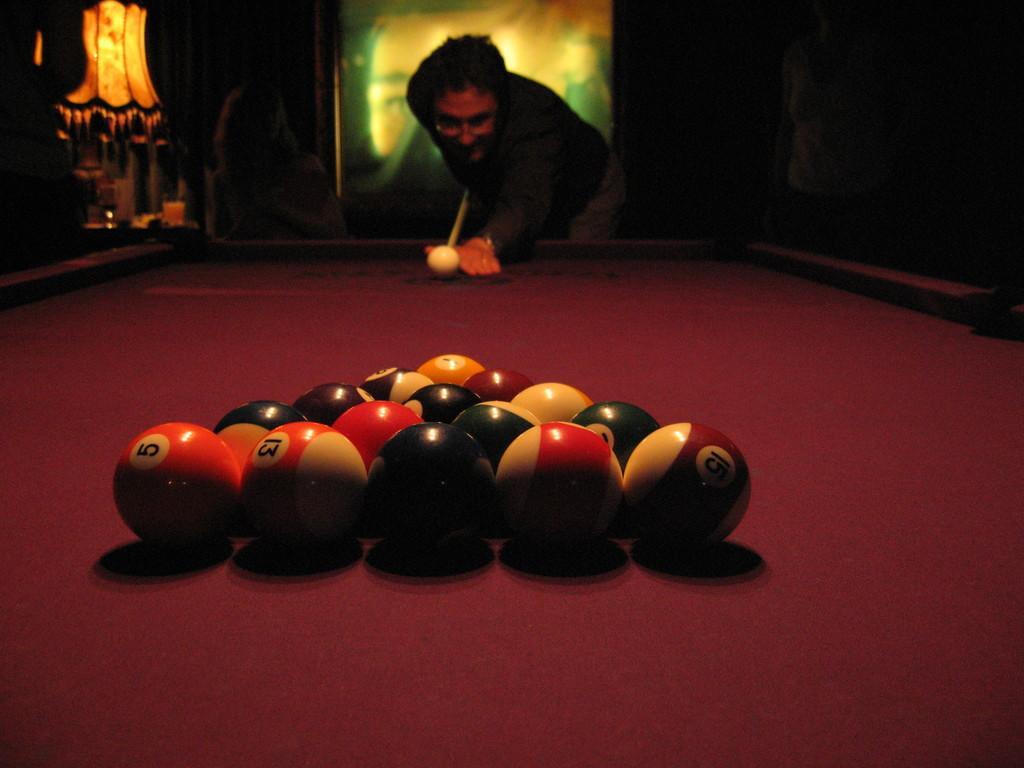Can you describe this image briefly? In this picture there is a man playing billiards. He is holding a stick in his hand. In front of him there is a billiards table and balls are placed on it. Beside him there is a woman and a table lamp on the table. In the background there is wall and frame. 